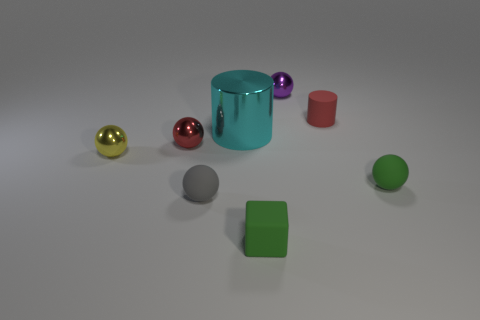The rubber cylinder has what color?
Your response must be concise. Red. How many objects are tiny objects that are on the right side of the tiny red metal thing or gray objects?
Ensure brevity in your answer.  5. There is a object in front of the gray rubber object; is its size the same as the cylinder that is left of the tiny purple sphere?
Keep it short and to the point. No. What number of objects are rubber things to the right of the red cylinder or rubber objects that are behind the small green matte block?
Give a very brief answer. 3. Do the tiny purple thing and the tiny yellow ball to the left of the small red rubber cylinder have the same material?
Your response must be concise. Yes. There is a tiny matte object that is behind the gray matte thing and in front of the small red cylinder; what is its shape?
Provide a short and direct response. Sphere. How many other things are there of the same color as the large shiny cylinder?
Give a very brief answer. 0. There is a gray object; what shape is it?
Provide a short and direct response. Sphere. There is a small rubber sphere that is to the right of the metallic ball to the right of the tiny green cube; what color is it?
Provide a short and direct response. Green. There is a cube; is it the same color as the tiny matte sphere that is right of the small purple metal thing?
Offer a very short reply. Yes. 